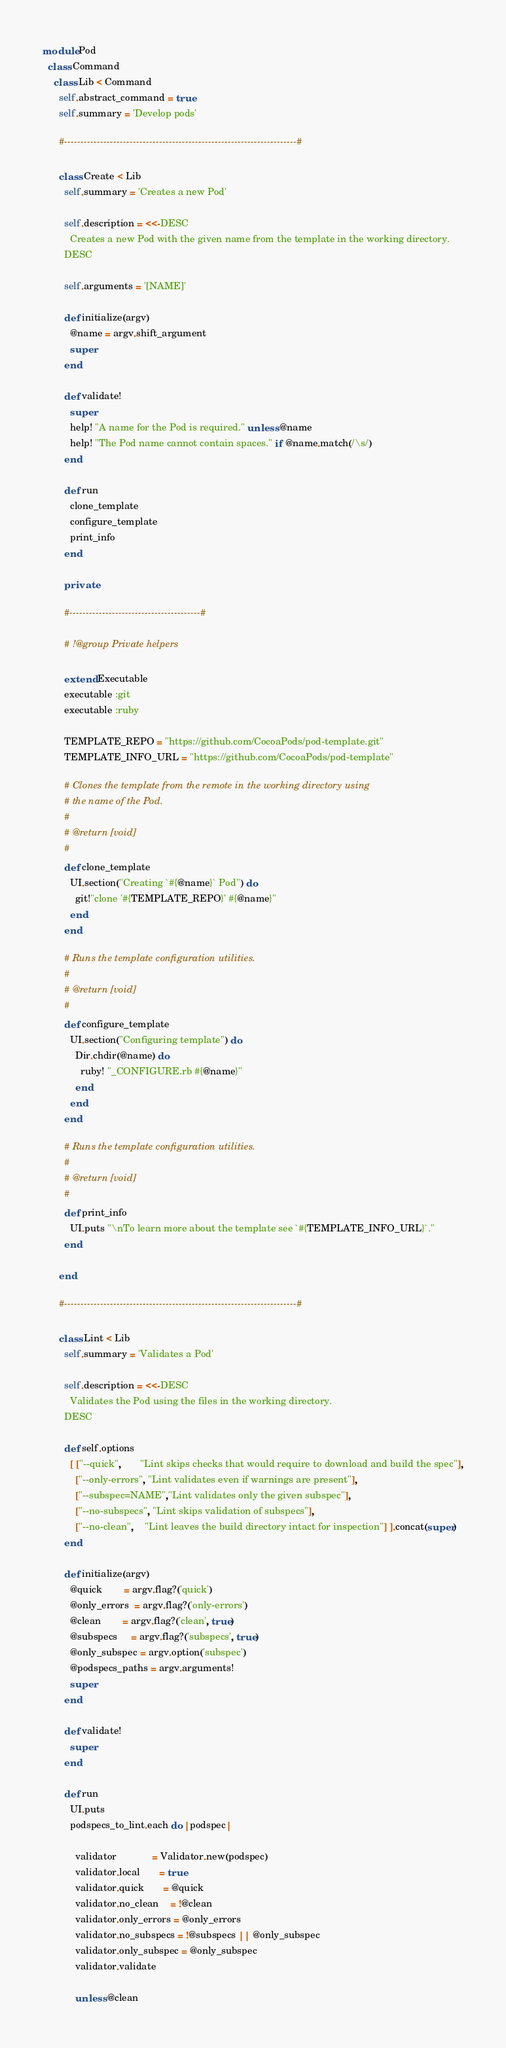Convert code to text. <code><loc_0><loc_0><loc_500><loc_500><_Ruby_>module Pod
  class Command
    class Lib < Command
      self.abstract_command = true
      self.summary = 'Develop pods'

      #-----------------------------------------------------------------------#

      class Create < Lib
        self.summary = 'Creates a new Pod'

        self.description = <<-DESC
          Creates a new Pod with the given name from the template in the working directory.
        DESC

        self.arguments = '[NAME]'

        def initialize(argv)
          @name = argv.shift_argument
          super
        end

        def validate!
          super
          help! "A name for the Pod is required." unless @name
          help! "The Pod name cannot contain spaces." if @name.match(/\s/)
        end

        def run
          clone_template
          configure_template
          print_info
        end

        private

        #----------------------------------------#

        # !@group Private helpers

        extend Executable
        executable :git
        executable :ruby

        TEMPLATE_REPO = "https://github.com/CocoaPods/pod-template.git"
        TEMPLATE_INFO_URL = "https://github.com/CocoaPods/pod-template"

        # Clones the template from the remote in the working directory using
        # the name of the Pod.
        #
        # @return [void]
        #
        def clone_template
          UI.section("Creating `#{@name}` Pod") do
            git!"clone '#{TEMPLATE_REPO}' #{@name}"
          end
        end

        # Runs the template configuration utilities.
        #
        # @return [void]
        #
        def configure_template
          UI.section("Configuring template") do
            Dir.chdir(@name) do
              ruby! "_CONFIGURE.rb #{@name}"
            end
          end
        end

        # Runs the template configuration utilities.
        #
        # @return [void]
        #
        def print_info
          UI.puts "\nTo learn more about the template see `#{TEMPLATE_INFO_URL}`."
        end

      end

      #-----------------------------------------------------------------------#

      class Lint < Lib
        self.summary = 'Validates a Pod'

        self.description = <<-DESC
          Validates the Pod using the files in the working directory.
        DESC

        def self.options
          [ ["--quick",       "Lint skips checks that would require to download and build the spec"],
            ["--only-errors", "Lint validates even if warnings are present"],
            ["--subspec=NAME","Lint validates only the given subspec"],
            ["--no-subspecs", "Lint skips validation of subspecs"],
            ["--no-clean",    "Lint leaves the build directory intact for inspection"] ].concat(super)
        end

        def initialize(argv)
          @quick        = argv.flag?('quick')
          @only_errors  = argv.flag?('only-errors')
          @clean        = argv.flag?('clean', true)
          @subspecs     = argv.flag?('subspecs', true)
          @only_subspec = argv.option('subspec')
          @podspecs_paths = argv.arguments!
          super
        end

        def validate!
          super
        end

        def run
          UI.puts
          podspecs_to_lint.each do |podspec|

            validator             = Validator.new(podspec)
            validator.local       = true
            validator.quick       = @quick
            validator.no_clean    = !@clean
            validator.only_errors = @only_errors
            validator.no_subspecs = !@subspecs || @only_subspec
            validator.only_subspec = @only_subspec
            validator.validate

            unless @clean</code> 